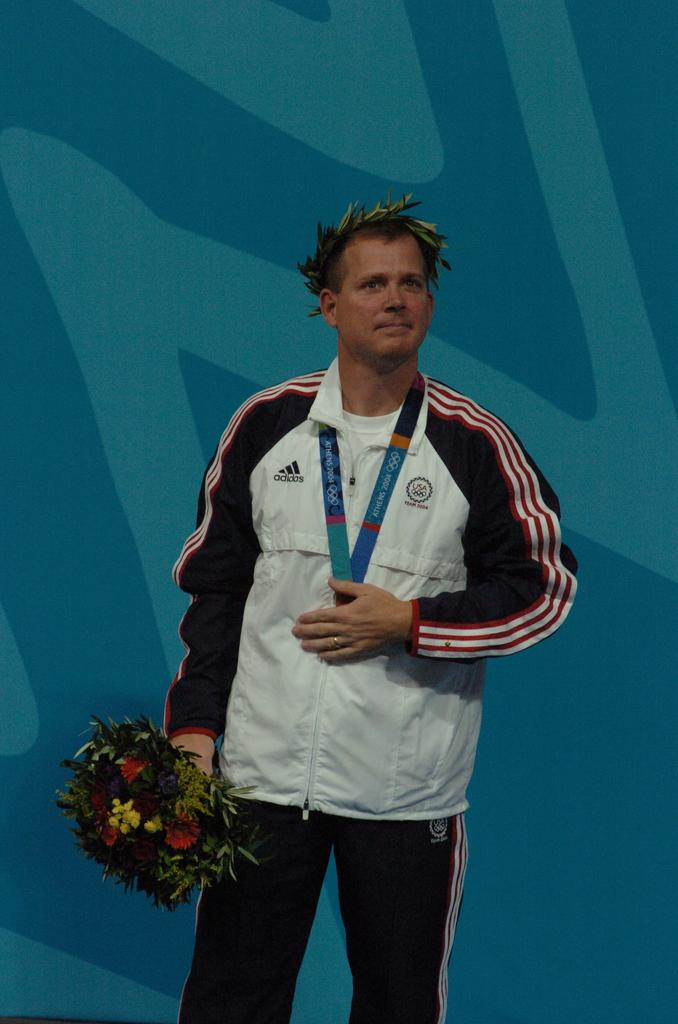<image>
Present a compact description of the photo's key features. A man with an Athens 2004 Olympic medal hanging around his neck is holding a bouquet. 